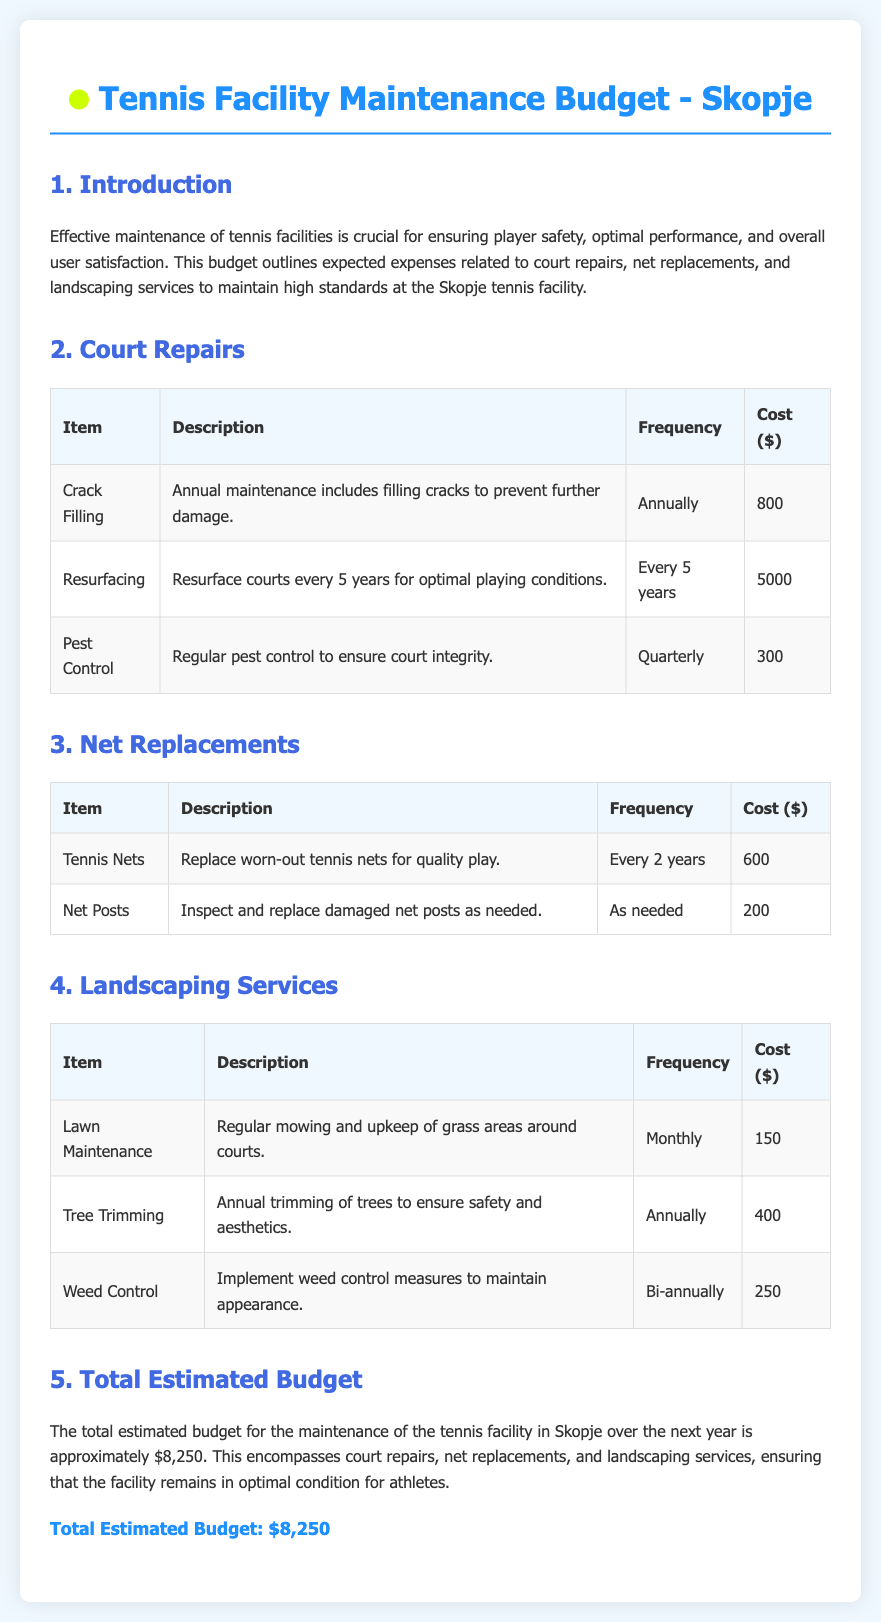what is the total estimated budget? The total estimated budget for the maintenance of the tennis facility in Skopje is stated at the end of the document, which is $8,250.
Answer: $8,250 how often does crack filling occur? The frequency of crack filling is listed in the court repairs section, which indicates it occurs annually.
Answer: Annually what is the cost of tennis nets replacement? The cost of replacing worn-out tennis nets is provided in the net replacements table, which states it is $600.
Answer: $600 what service is performed monthly? The landscaping services section lists lawn maintenance, which is performed monthly.
Answer: Lawn Maintenance how frequently is weed control implemented? The document specifies that weed control measures are implemented bi-annually in the landscaping services section.
Answer: Bi-annually what is the cost for tree trimming? The cost for annual trimming of trees for aesthetics is detailed in the landscaping services section, which states it is $400.
Answer: $400 how often are courts resurfaced? The document states that resurfacing occurs every 5 years, according to the court repairs section.
Answer: Every 5 years what is the purpose of pest control? The purpose of pest control is described in the court repairs section, indicating it is to ensure court integrity.
Answer: Court Integrity how much does monthly lawn maintenance cost? The document specifies the cost of monthly lawn maintenance to be $150 in the landscaping services section.
Answer: $150 